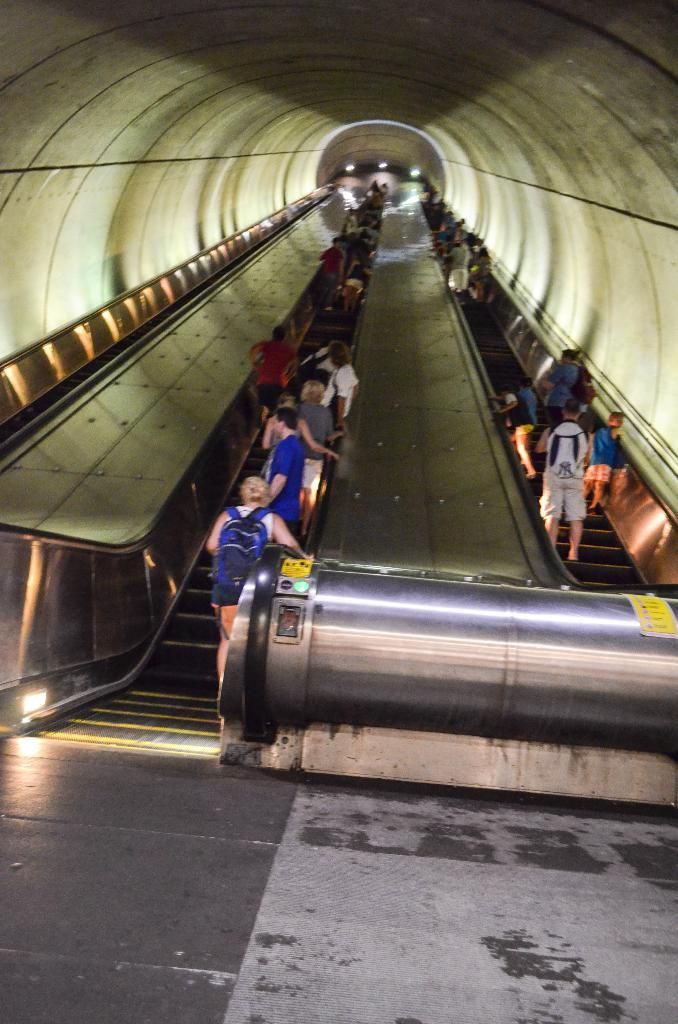What type of structure is visible in the image? There are stairs in the image. What color are some of the objects in the image? There are yellow objects in the image. Who is present in the image? There are people standing in the image. What are some of the people doing in the image? Some of the people are carrying bags. What news is being discussed by the people in the image? There is no indication in the image that the people are discussing any news. 